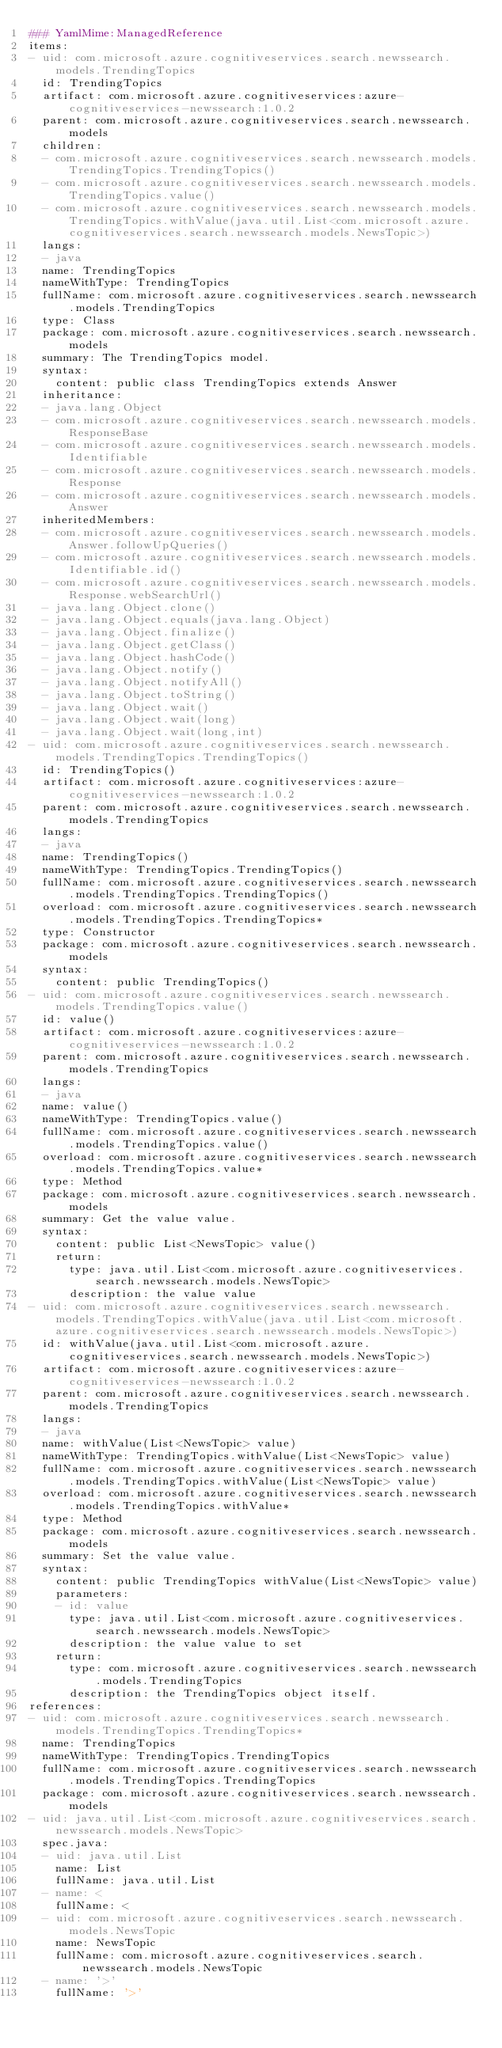<code> <loc_0><loc_0><loc_500><loc_500><_YAML_>### YamlMime:ManagedReference
items:
- uid: com.microsoft.azure.cognitiveservices.search.newssearch.models.TrendingTopics
  id: TrendingTopics
  artifact: com.microsoft.azure.cognitiveservices:azure-cognitiveservices-newssearch:1.0.2
  parent: com.microsoft.azure.cognitiveservices.search.newssearch.models
  children:
  - com.microsoft.azure.cognitiveservices.search.newssearch.models.TrendingTopics.TrendingTopics()
  - com.microsoft.azure.cognitiveservices.search.newssearch.models.TrendingTopics.value()
  - com.microsoft.azure.cognitiveservices.search.newssearch.models.TrendingTopics.withValue(java.util.List<com.microsoft.azure.cognitiveservices.search.newssearch.models.NewsTopic>)
  langs:
  - java
  name: TrendingTopics
  nameWithType: TrendingTopics
  fullName: com.microsoft.azure.cognitiveservices.search.newssearch.models.TrendingTopics
  type: Class
  package: com.microsoft.azure.cognitiveservices.search.newssearch.models
  summary: The TrendingTopics model.
  syntax:
    content: public class TrendingTopics extends Answer
  inheritance:
  - java.lang.Object
  - com.microsoft.azure.cognitiveservices.search.newssearch.models.ResponseBase
  - com.microsoft.azure.cognitiveservices.search.newssearch.models.Identifiable
  - com.microsoft.azure.cognitiveservices.search.newssearch.models.Response
  - com.microsoft.azure.cognitiveservices.search.newssearch.models.Answer
  inheritedMembers:
  - com.microsoft.azure.cognitiveservices.search.newssearch.models.Answer.followUpQueries()
  - com.microsoft.azure.cognitiveservices.search.newssearch.models.Identifiable.id()
  - com.microsoft.azure.cognitiveservices.search.newssearch.models.Response.webSearchUrl()
  - java.lang.Object.clone()
  - java.lang.Object.equals(java.lang.Object)
  - java.lang.Object.finalize()
  - java.lang.Object.getClass()
  - java.lang.Object.hashCode()
  - java.lang.Object.notify()
  - java.lang.Object.notifyAll()
  - java.lang.Object.toString()
  - java.lang.Object.wait()
  - java.lang.Object.wait(long)
  - java.lang.Object.wait(long,int)
- uid: com.microsoft.azure.cognitiveservices.search.newssearch.models.TrendingTopics.TrendingTopics()
  id: TrendingTopics()
  artifact: com.microsoft.azure.cognitiveservices:azure-cognitiveservices-newssearch:1.0.2
  parent: com.microsoft.azure.cognitiveservices.search.newssearch.models.TrendingTopics
  langs:
  - java
  name: TrendingTopics()
  nameWithType: TrendingTopics.TrendingTopics()
  fullName: com.microsoft.azure.cognitiveservices.search.newssearch.models.TrendingTopics.TrendingTopics()
  overload: com.microsoft.azure.cognitiveservices.search.newssearch.models.TrendingTopics.TrendingTopics*
  type: Constructor
  package: com.microsoft.azure.cognitiveservices.search.newssearch.models
  syntax:
    content: public TrendingTopics()
- uid: com.microsoft.azure.cognitiveservices.search.newssearch.models.TrendingTopics.value()
  id: value()
  artifact: com.microsoft.azure.cognitiveservices:azure-cognitiveservices-newssearch:1.0.2
  parent: com.microsoft.azure.cognitiveservices.search.newssearch.models.TrendingTopics
  langs:
  - java
  name: value()
  nameWithType: TrendingTopics.value()
  fullName: com.microsoft.azure.cognitiveservices.search.newssearch.models.TrendingTopics.value()
  overload: com.microsoft.azure.cognitiveservices.search.newssearch.models.TrendingTopics.value*
  type: Method
  package: com.microsoft.azure.cognitiveservices.search.newssearch.models
  summary: Get the value value.
  syntax:
    content: public List<NewsTopic> value()
    return:
      type: java.util.List<com.microsoft.azure.cognitiveservices.search.newssearch.models.NewsTopic>
      description: the value value
- uid: com.microsoft.azure.cognitiveservices.search.newssearch.models.TrendingTopics.withValue(java.util.List<com.microsoft.azure.cognitiveservices.search.newssearch.models.NewsTopic>)
  id: withValue(java.util.List<com.microsoft.azure.cognitiveservices.search.newssearch.models.NewsTopic>)
  artifact: com.microsoft.azure.cognitiveservices:azure-cognitiveservices-newssearch:1.0.2
  parent: com.microsoft.azure.cognitiveservices.search.newssearch.models.TrendingTopics
  langs:
  - java
  name: withValue(List<NewsTopic> value)
  nameWithType: TrendingTopics.withValue(List<NewsTopic> value)
  fullName: com.microsoft.azure.cognitiveservices.search.newssearch.models.TrendingTopics.withValue(List<NewsTopic> value)
  overload: com.microsoft.azure.cognitiveservices.search.newssearch.models.TrendingTopics.withValue*
  type: Method
  package: com.microsoft.azure.cognitiveservices.search.newssearch.models
  summary: Set the value value.
  syntax:
    content: public TrendingTopics withValue(List<NewsTopic> value)
    parameters:
    - id: value
      type: java.util.List<com.microsoft.azure.cognitiveservices.search.newssearch.models.NewsTopic>
      description: the value value to set
    return:
      type: com.microsoft.azure.cognitiveservices.search.newssearch.models.TrendingTopics
      description: the TrendingTopics object itself.
references:
- uid: com.microsoft.azure.cognitiveservices.search.newssearch.models.TrendingTopics.TrendingTopics*
  name: TrendingTopics
  nameWithType: TrendingTopics.TrendingTopics
  fullName: com.microsoft.azure.cognitiveservices.search.newssearch.models.TrendingTopics.TrendingTopics
  package: com.microsoft.azure.cognitiveservices.search.newssearch.models
- uid: java.util.List<com.microsoft.azure.cognitiveservices.search.newssearch.models.NewsTopic>
  spec.java:
  - uid: java.util.List
    name: List
    fullName: java.util.List
  - name: <
    fullName: <
  - uid: com.microsoft.azure.cognitiveservices.search.newssearch.models.NewsTopic
    name: NewsTopic
    fullName: com.microsoft.azure.cognitiveservices.search.newssearch.models.NewsTopic
  - name: '>'
    fullName: '>'</code> 